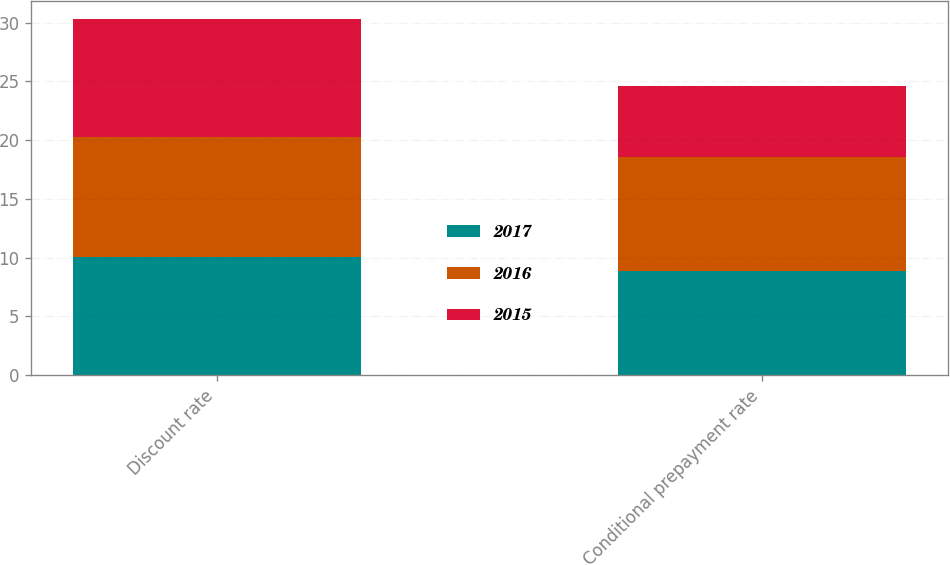Convert chart to OTSL. <chart><loc_0><loc_0><loc_500><loc_500><stacked_bar_chart><ecel><fcel>Discount rate<fcel>Conditional prepayment rate<nl><fcel>2017<fcel>10.06<fcel>8.88<nl><fcel>2016<fcel>10.16<fcel>9.66<nl><fcel>2015<fcel>10.11<fcel>6.03<nl></chart> 